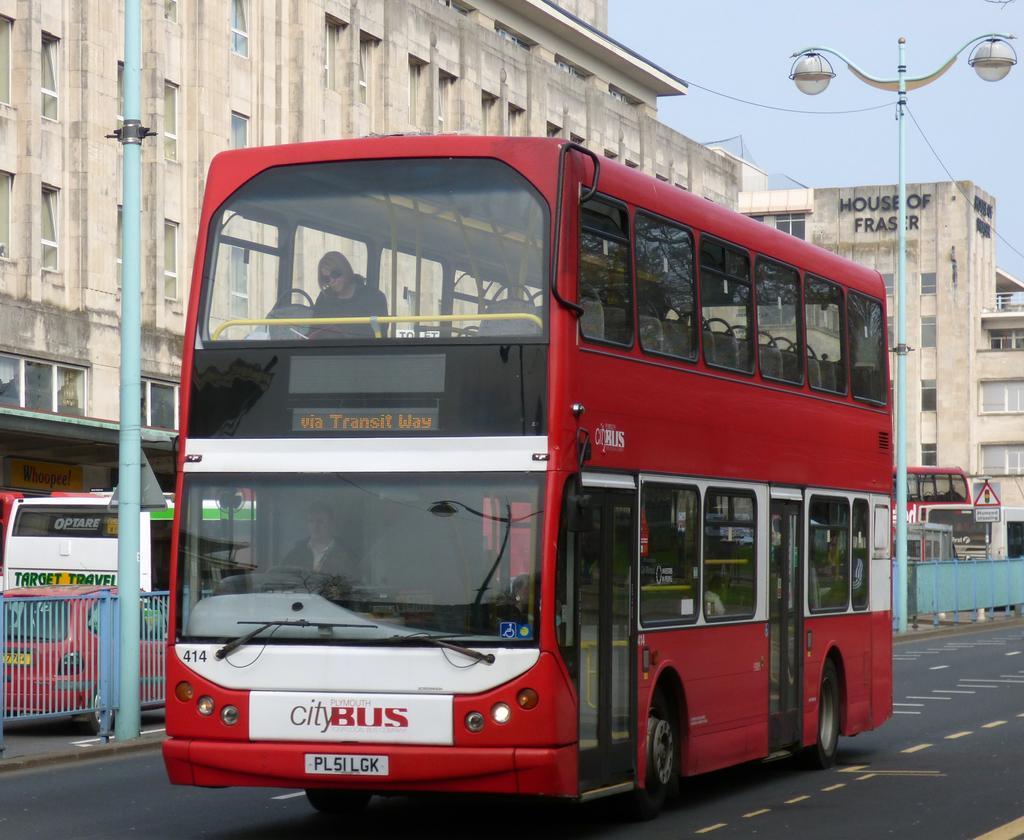Please provide a concise description of this image. In this image we can see many vehicles. There is a sky and few buildings in the image. There are two street lights in the image. An electrical cable is connected to the street light. A person is driving a bus. 